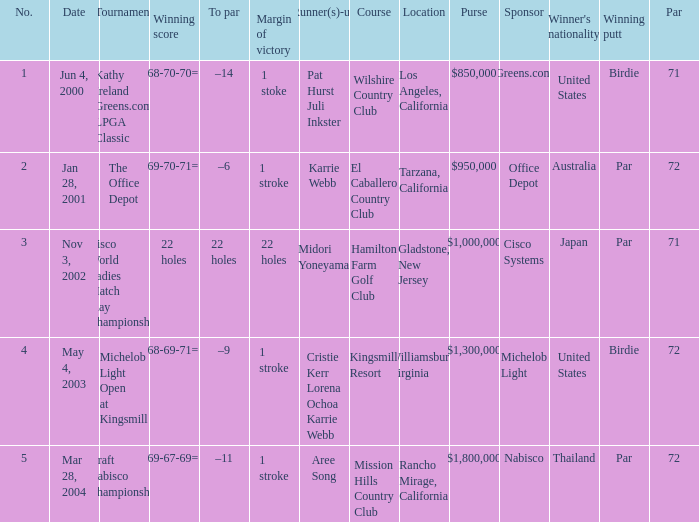Where is the margin of victory dated mar 28, 2004? 1 stroke. 